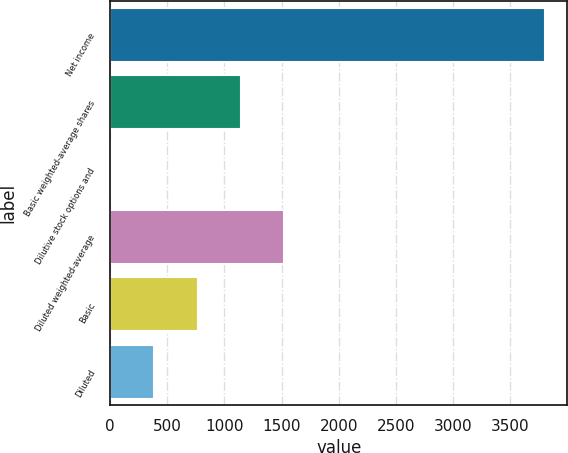Convert chart. <chart><loc_0><loc_0><loc_500><loc_500><bar_chart><fcel>Net income<fcel>Basic weighted-average shares<fcel>Dilutive stock options and<fcel>Diluted weighted-average<fcel>Basic<fcel>Diluted<nl><fcel>3808<fcel>1144.5<fcel>3<fcel>1525<fcel>764<fcel>383.5<nl></chart> 